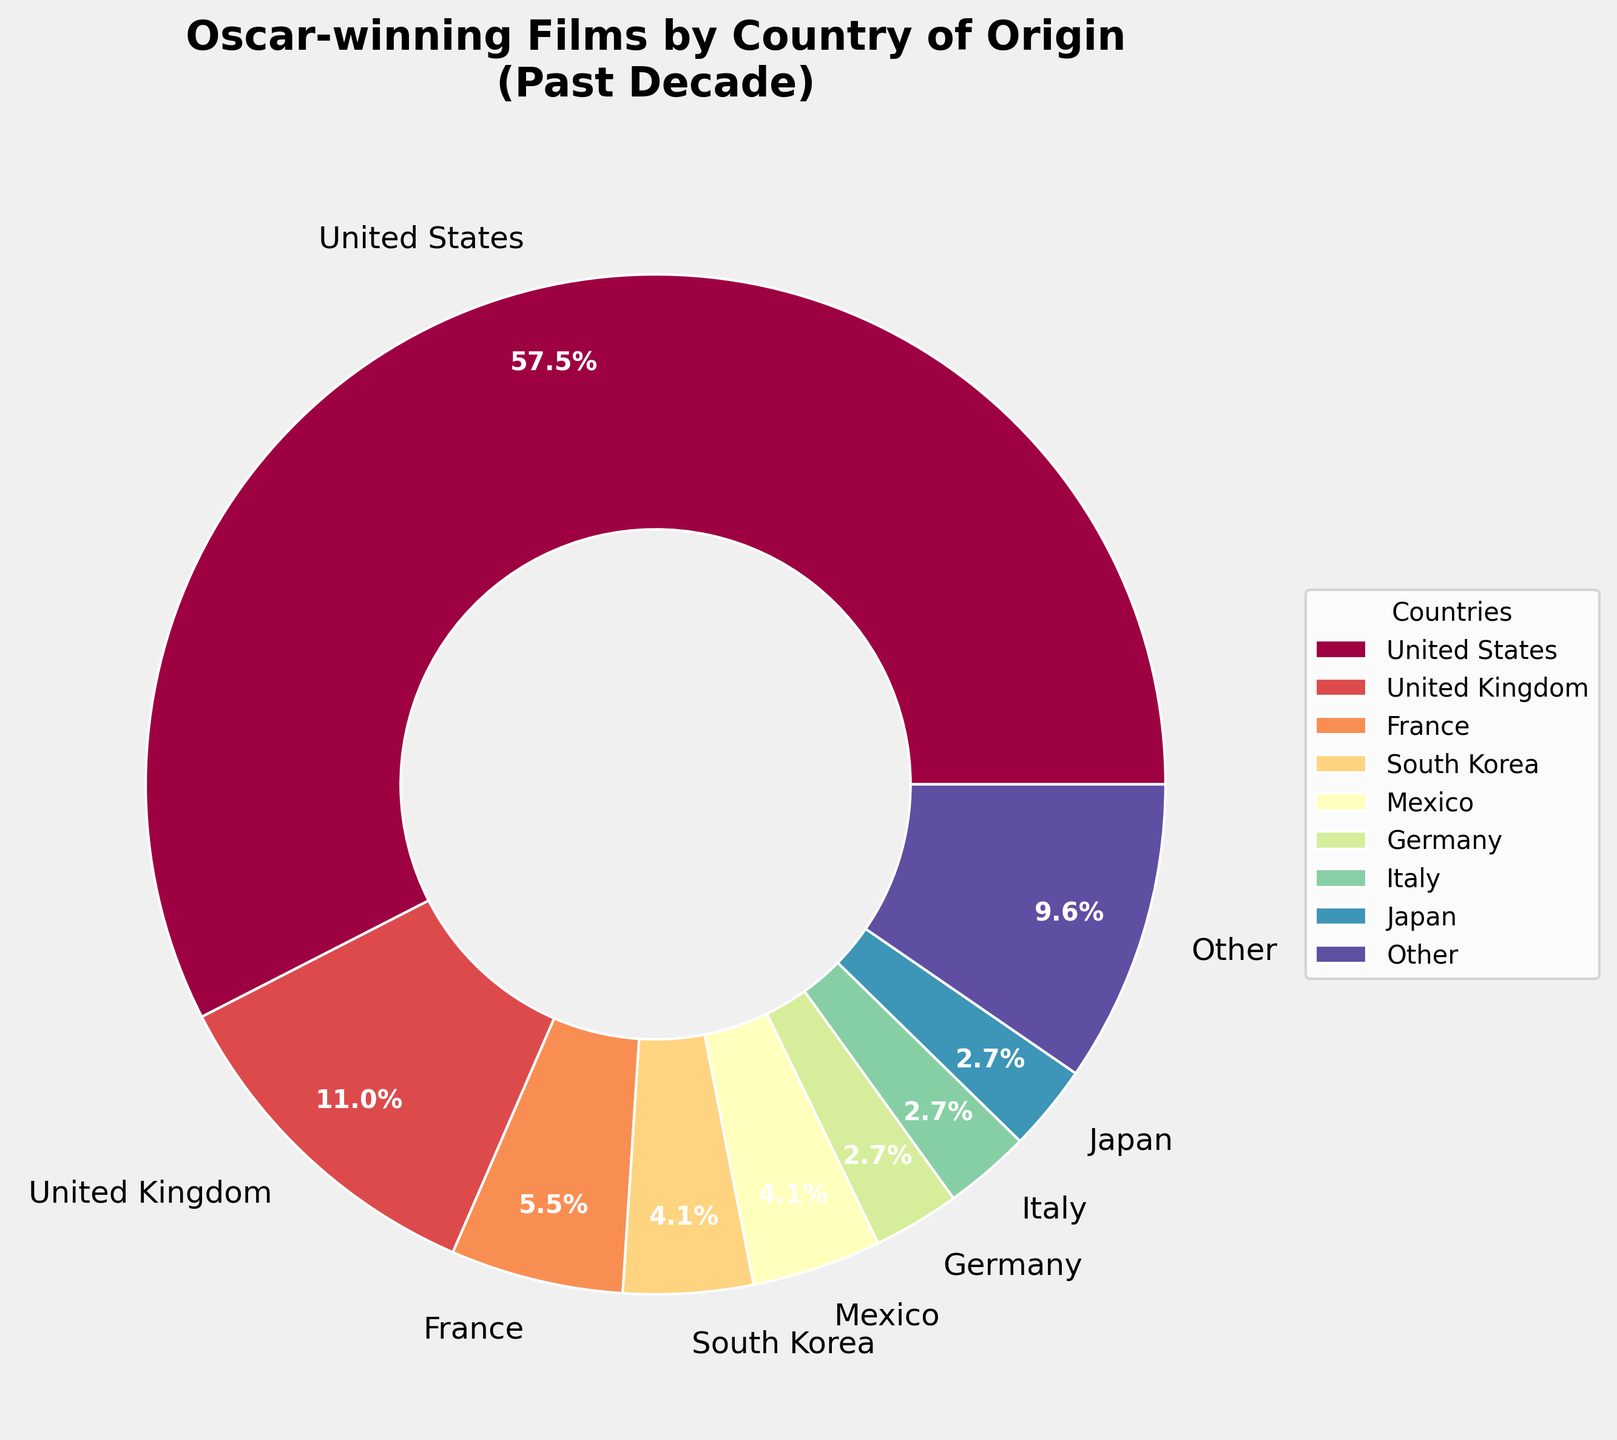Which country has the highest number of Oscar-winning films? The pie chart shows that the United States has the most significant portion, indicating it has the highest number of Oscar-winning films.
Answer: United States What percentage of Oscar-winning films came from countries with fewer than 2 wins each? The 'Other' category in the pie chart represents countries with fewer than 2 wins. According to the chart, 'Other' makes up a specific percentage of the total.
Answer: 8.5% How many countries have exactly 2 Oscar-winning films? From the pie chart labels, the countries with exactly 2 films are Germany, Italy, and Japan. Count these countries.
Answer: 3 What is the total count of Oscar-winning films from Europe, according to the pie chart? Identify the European countries on the chart: United Kingdom (8), France (4), Germany (2), Italy (2), Spain (1), Denmark (1), Poland (1). Sum these numbers.
Answer: 19 Compare the number of Oscar-winning films from the United Kingdom and Mexico. Which country has more, and by how much? The UK has 8 Oscar-winning films and Mexico has 3. Subtract Mexico's count from the UK's count.
Answer: United Kingdom by 5 Which country has the smallest percentage of the total Oscar-winning films shown in the pie chart? From the pie chart labels, 'Other' has the smallest portion, representing multiple countries with a combined lesser number of wins individually. If considering specific countries individually, pick the smallest slice not in 'Other'.
Answer: Each of Iran, Poland, Argentina, New Zealand, Canada, and Spain (1 each) What is the approximate combined percentage of Oscar-winning films coming from South Korea and Japan? According to the chart, South Korea has 3 films and Japan has 2. Sum these numbers to get 5. Calculate the percentage: (5/72) ≈ 6.9%.
Answer: 6.9% Which continent dominates the pie chart in terms of Oscar-winning films? By examining the origins of the countries in the pie chart, one can see that most countries with high or moderate winning counts are from North America and Europe. The United States alone has a significant slice.
Answer: North America 